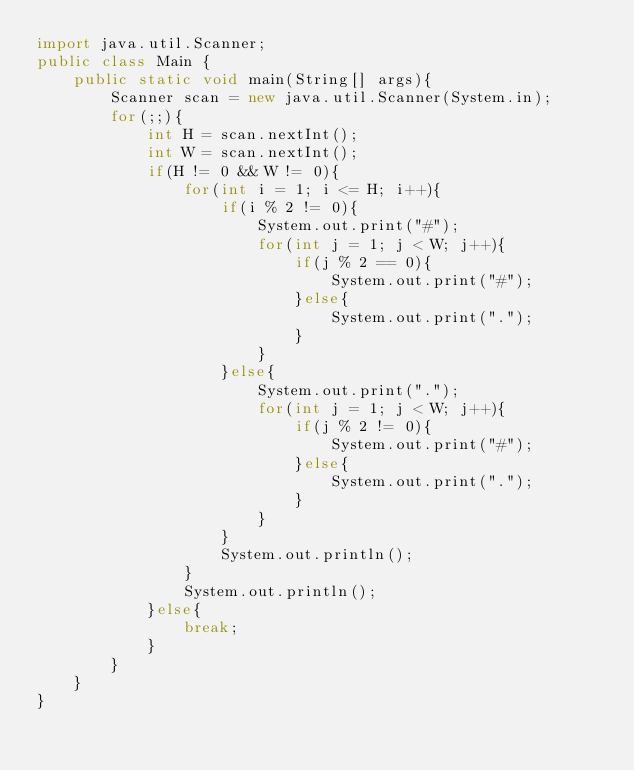<code> <loc_0><loc_0><loc_500><loc_500><_Java_>import java.util.Scanner;
public class Main {
    public static void main(String[] args){
        Scanner scan = new java.util.Scanner(System.in);
        for(;;){
            int H = scan.nextInt();
            int W = scan.nextInt();
            if(H != 0 && W != 0){
                for(int i = 1; i <= H; i++){
                    if(i % 2 != 0){
                        System.out.print("#");
                        for(int j = 1; j < W; j++){
                            if(j % 2 == 0){
                                System.out.print("#");
                            }else{
                                System.out.print(".");
                            }
                        }
                    }else{
                        System.out.print(".");
                        for(int j = 1; j < W; j++){
                            if(j % 2 != 0){
                                System.out.print("#");
                            }else{
                                System.out.print(".");
                            }
                        }
                    }
                    System.out.println();
                }
                System.out.println();
            }else{
                break;
            }
        }
    }
}</code> 